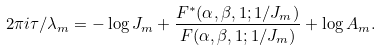<formula> <loc_0><loc_0><loc_500><loc_500>2 \pi i \tau / \lambda _ { m } = - \log J _ { m } + \frac { F ^ { * } ( \alpha , \beta , 1 ; 1 / J _ { m } ) } { F ( \alpha , \beta , 1 ; 1 / J _ { m } ) } + \log A _ { m } .</formula> 